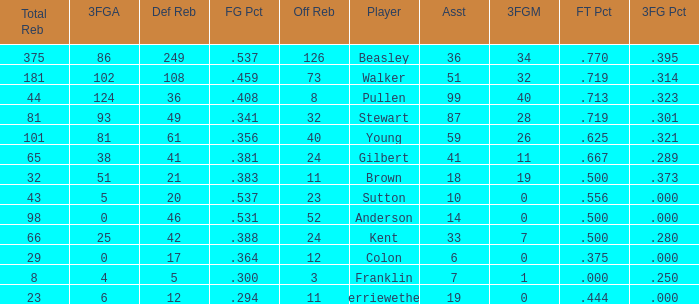What is the total number of offensive rebounds for players with under 65 total rebounds, 5 defensive rebounds, and under 7 assists? 0.0. 